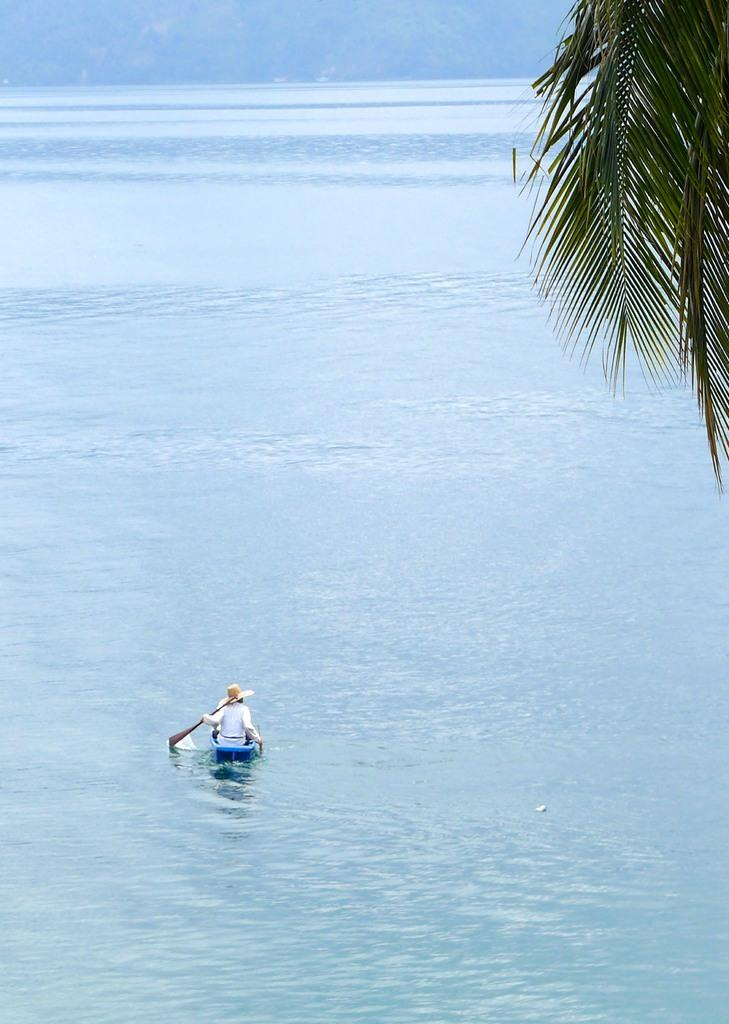What is the person in the image doing? The person is sitting in the boat. What is the person holding in the image? The person is holding a paddle. Where is the boat located in the image? The boat is on the water. What can be seen in the background of the image? There is a tree visible in the image. How does the person drive the boat in the image? The person is not driving the boat in the image; they are using a paddle to propel the boat. 